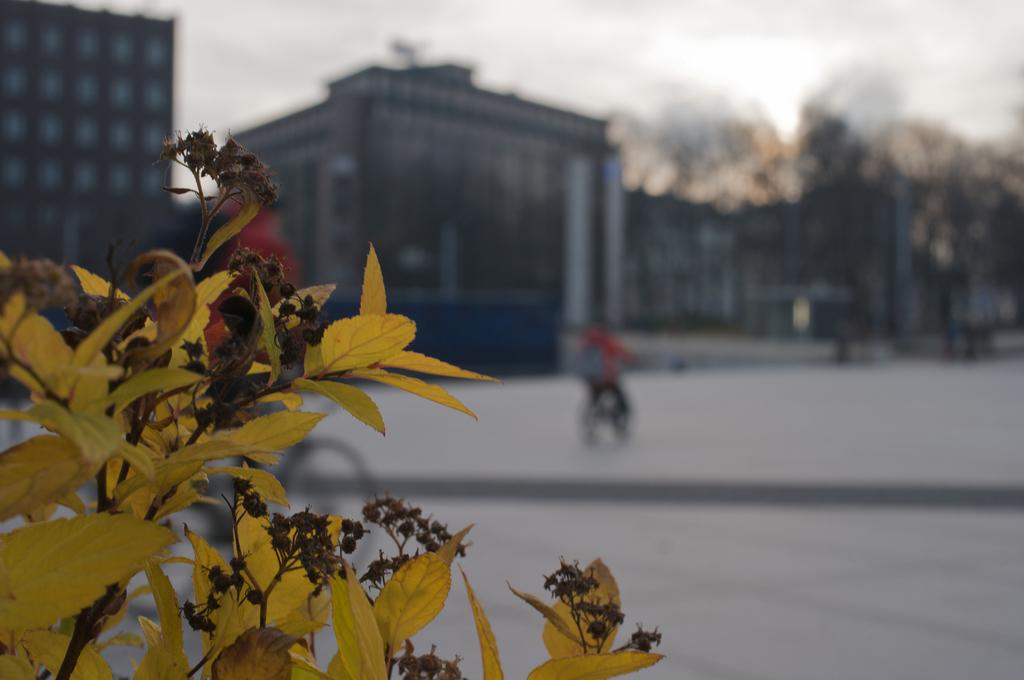What is present in the image? There is a plant in the image. What can be seen in the background of the image? There are buildings and trees in the background of the image. What activity is being performed by a person in the background of the image? A person is riding a bicycle in the background of the image. How many jellyfish can be seen swimming in the water in the image? There is no water or jellyfish present in the image. 